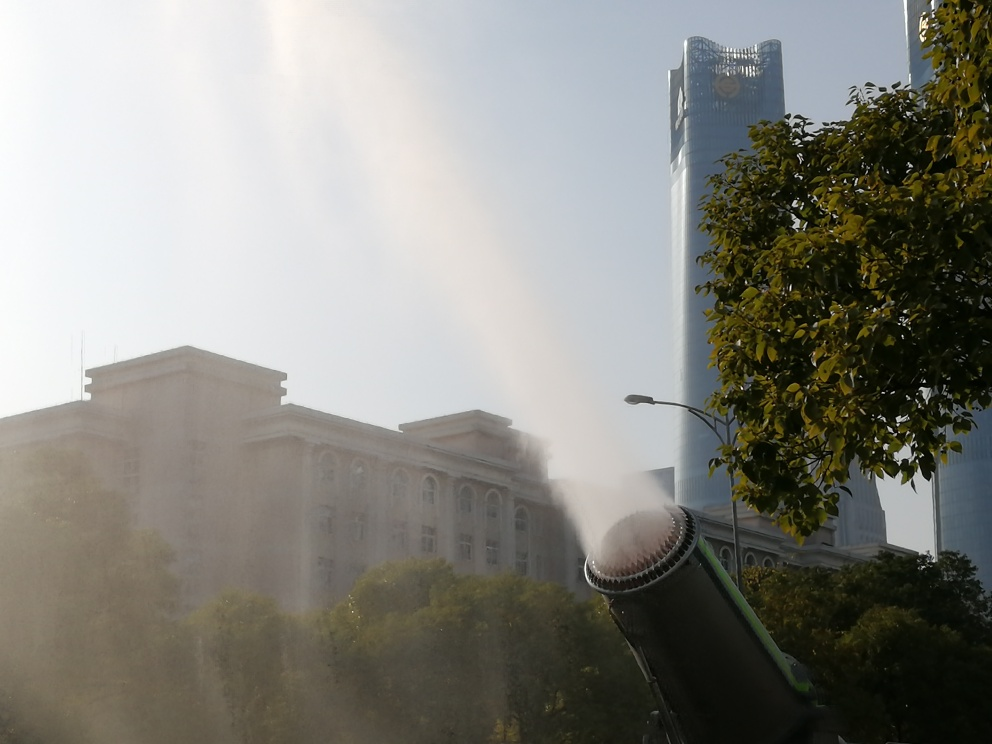Can you describe the different architectural styles in the image? Certainly. In the foreground, we have a classical building with features like columns and ornate windows, indicative of neoclassical architecture. In contrast, the background showcases a modern skyscraper with a sleek, glass facade, emphasizing the blend of historical and contemporary design elements within the city's skyline. Does this contrast tell us something about the city? Yes, it suggests that the city values both its historical heritage and modern development. This coexistence indicates a respect for tradition alongside growth and progress, which can be a sign of a culturally rich and economically vibrant urban environment. 